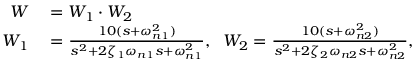Convert formula to latex. <formula><loc_0><loc_0><loc_500><loc_500>\begin{array} { r l } { W } & = W _ { 1 } \cdot W _ { 2 } } \\ { W _ { 1 } } & = \frac { 1 0 ( s + \omega _ { n 1 } ^ { 2 } ) } { s ^ { 2 } + 2 \zeta _ { 1 } \omega _ { n 1 } s + \omega _ { n 1 } ^ { 2 } } , \, W _ { 2 } = \frac { 1 0 ( s + \omega _ { n 2 } ^ { 2 } ) } { s ^ { 2 } + 2 \zeta _ { 2 } \omega _ { n 2 } s + \omega _ { n 2 } ^ { 2 } } , } \end{array}</formula> 